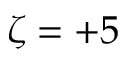Convert formula to latex. <formula><loc_0><loc_0><loc_500><loc_500>\zeta = + 5</formula> 